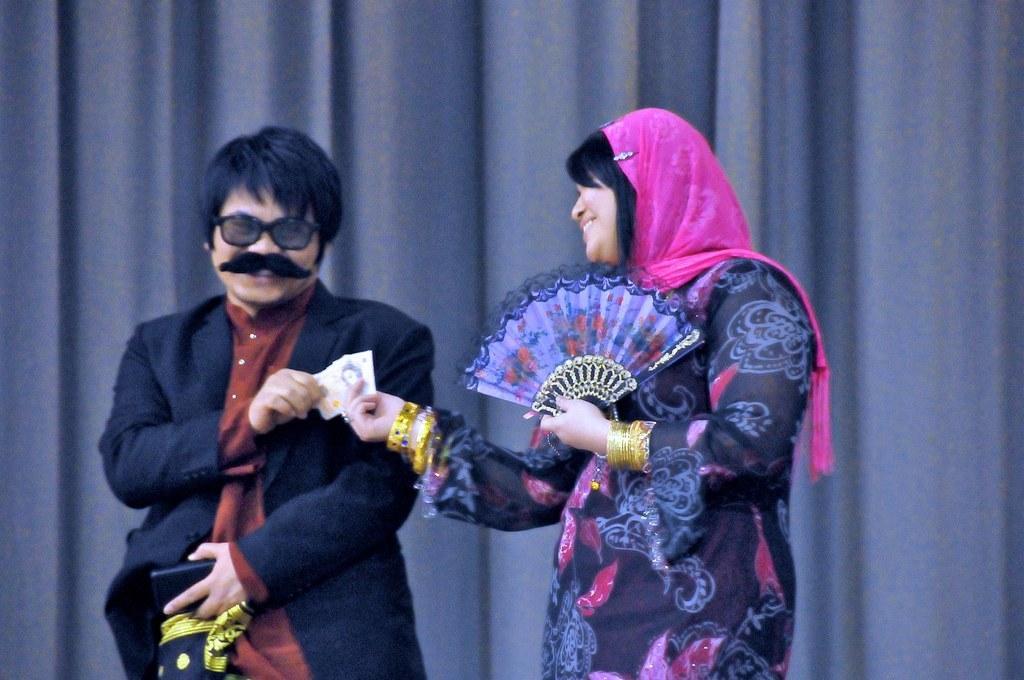Please provide a concise description of this image. In this image we can see two people standing. One man is holding cards and an object in his hands. One woman is holding a hand fan in her hand. At the top of the image we can see curtain. 